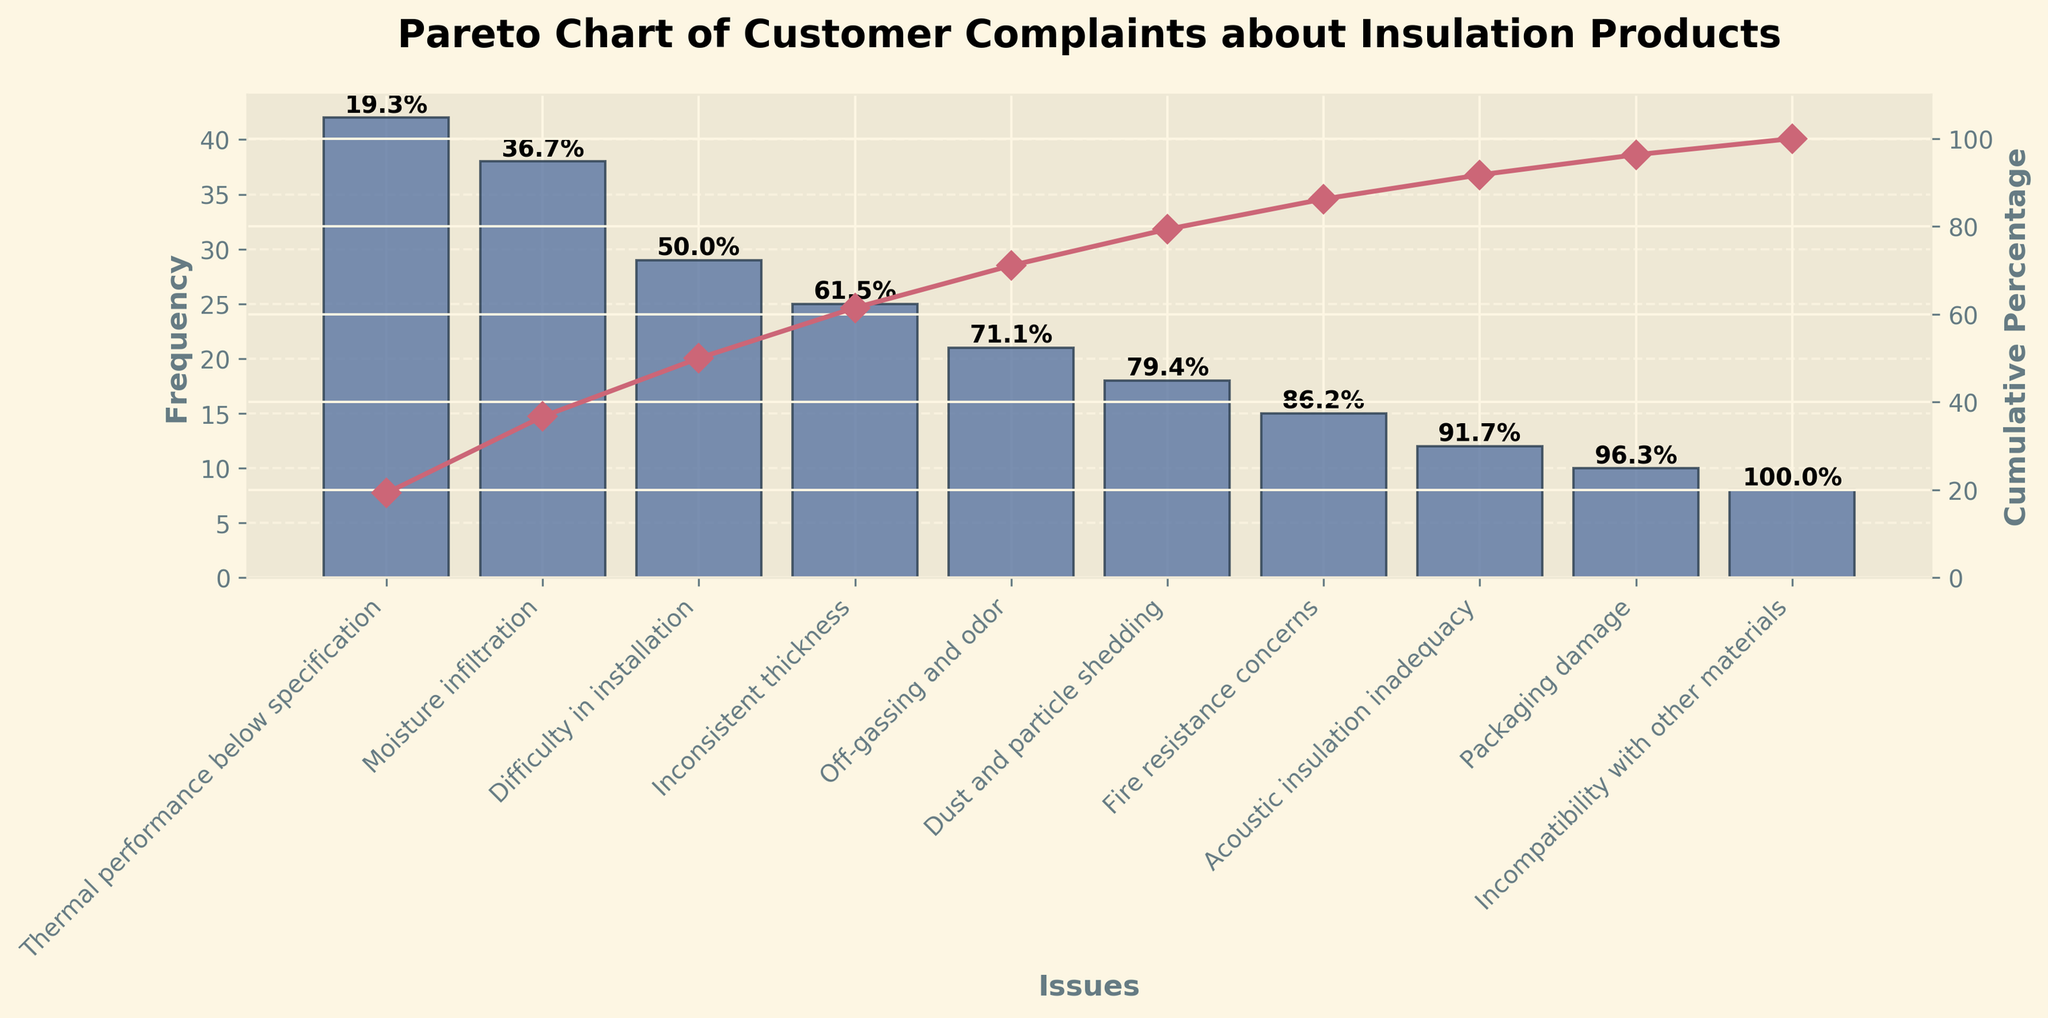What is the title of the figure? The title is usually placed at the top of the chart. In this case, the prominent and bold text at the top reads "Pareto Chart of Customer Complaints about Insulation Products."
Answer: Pareto Chart of Customer Complaints about Insulation Products How many different customer complaints are documented in the chart? The x-axis lists the different issues. By counting the labels, we can see that there are 10 different customer complaints.
Answer: 10 Which issue has the highest frequency of complaints? The highest bar in the chart corresponds to the issue with the highest frequency. The label below this bar reads "Thermal performance below specification."
Answer: Thermal performance below specification What is the cumulative percentage for "Difficulty in installation"? To find this, look at the bar for "Difficulty in installation" and refer to the overlaid cumulative percentage text above it. The bar's cumulative percentage is marked as 71.0%.
Answer: 71.0% Which issue has the lowest frequency of complaints? The shortest bar in the chart represents the issue with the lowest frequency. The label below this bar reads "Incompatibility with other materials."
Answer: Incompatibility with other materials What is the cumulative percentage after the first three issues? Add the cumulative percentages of the first three issues. "Thermal performance below specification" is 31.3%, "Moisture infiltration" is 60.6%, and "Difficulty in installation" is 71.0%. However, the sum is not straightforward based on the chart alone because we're reading the predefined cumulative percentages. The cumulative percentage after the first three is shown as 71.0%.
Answer: 71.0% What is the combined frequency of the top two issues? "Thermal performance below specification" has a frequency of 42, and "Moisture infiltration" has a frequency of 38. Adding these together, 42 + 38 = 80.
Answer: 80 What percentage of complaints are due to "Off-gassing and odor" or lower ranked issues? The cumulative percentage at the top of the "Off-gassing and odor" bar is 80.7%. So, the remaining percentage is 100% - 80.7% = 19.3%.
Answer: 19.3% Which issue has more complaints: "Fire resistance concerns" or "Acoustic insulation inadequacy"? By comparing the heights of the bars and their labels, it can be observed that the bar for "Fire resistance concerns" is higher than the one for "Acoustic insulation inadequacy." "Fire resistance concerns" has a frequency of 15, while "Acoustic insulation inadequacy" has a frequency of 12.
Answer: Fire resistance concerns How does the frequency of "Dust and particle shedding" compare to "Inconsistent thickness"? The bar for "Dust and particle shedding" is shorter than the one for "Inconsistent thickness." Specifically, "Dust and particle shedding" has a frequency of 18 and "Inconsistent thickness" has a frequency of 25, so the difference is 25 - 18 = 7.
Answer: Inconsistent thickness is 7 higher than Dust and particle shedding 